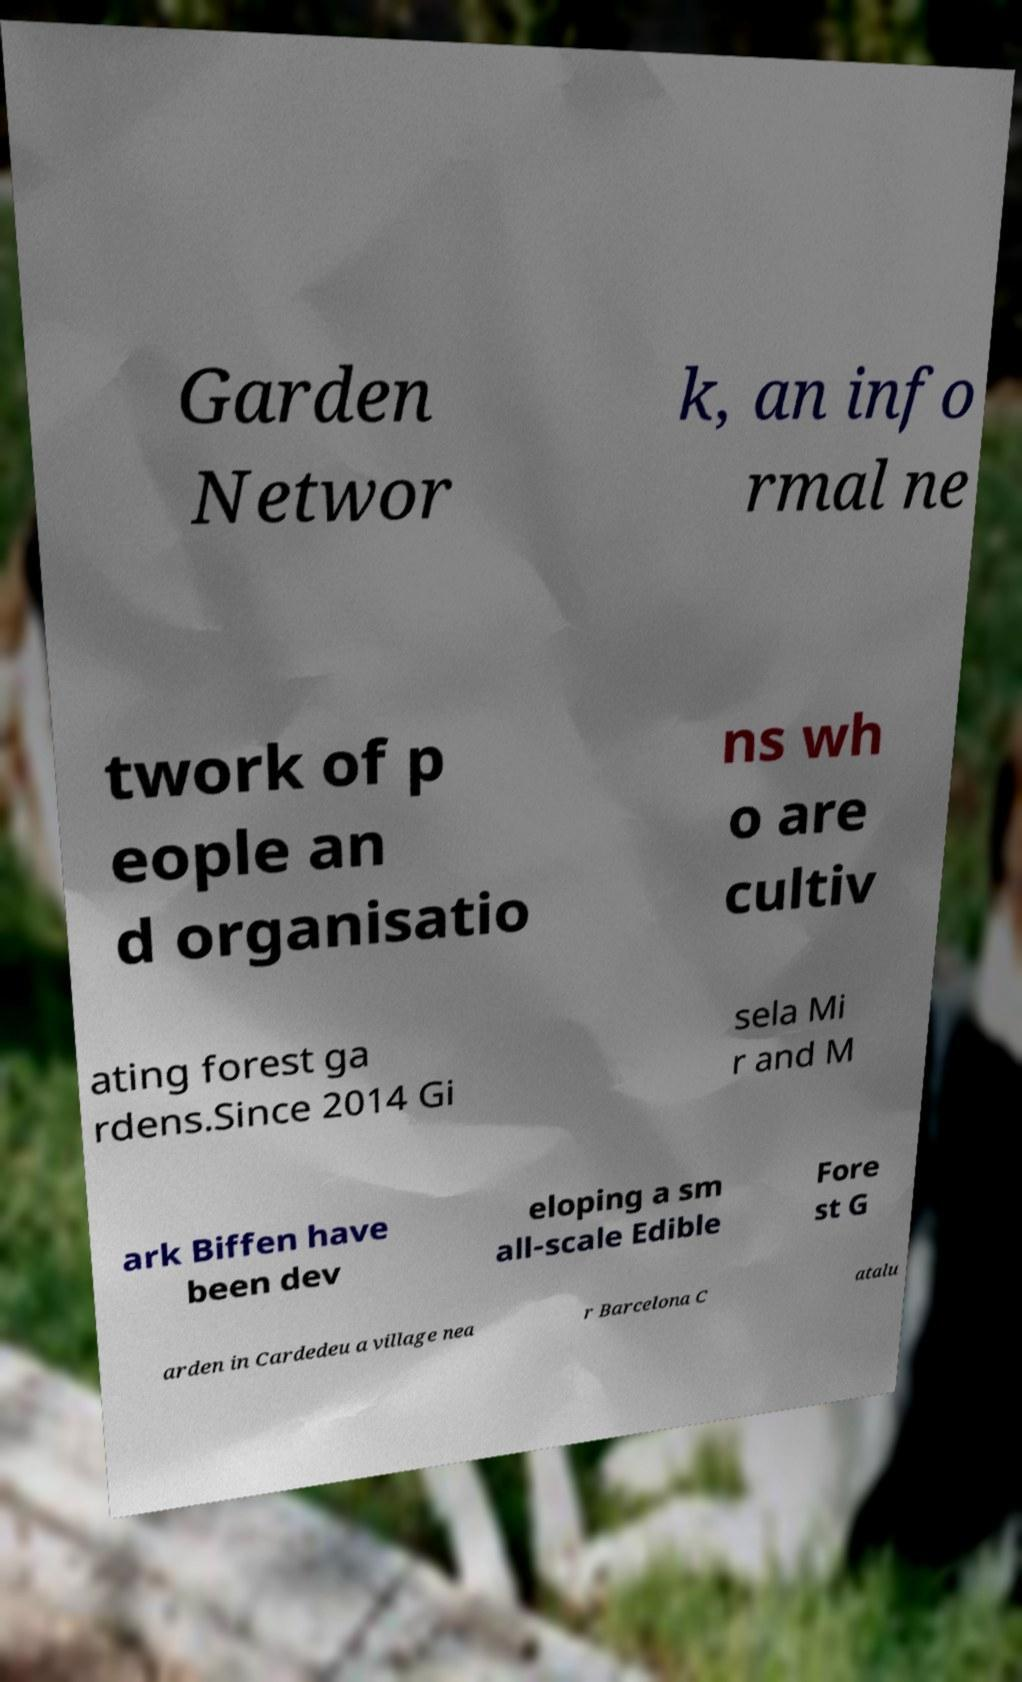What messages or text are displayed in this image? I need them in a readable, typed format. Garden Networ k, an info rmal ne twork of p eople an d organisatio ns wh o are cultiv ating forest ga rdens.Since 2014 Gi sela Mi r and M ark Biffen have been dev eloping a sm all-scale Edible Fore st G arden in Cardedeu a village nea r Barcelona C atalu 